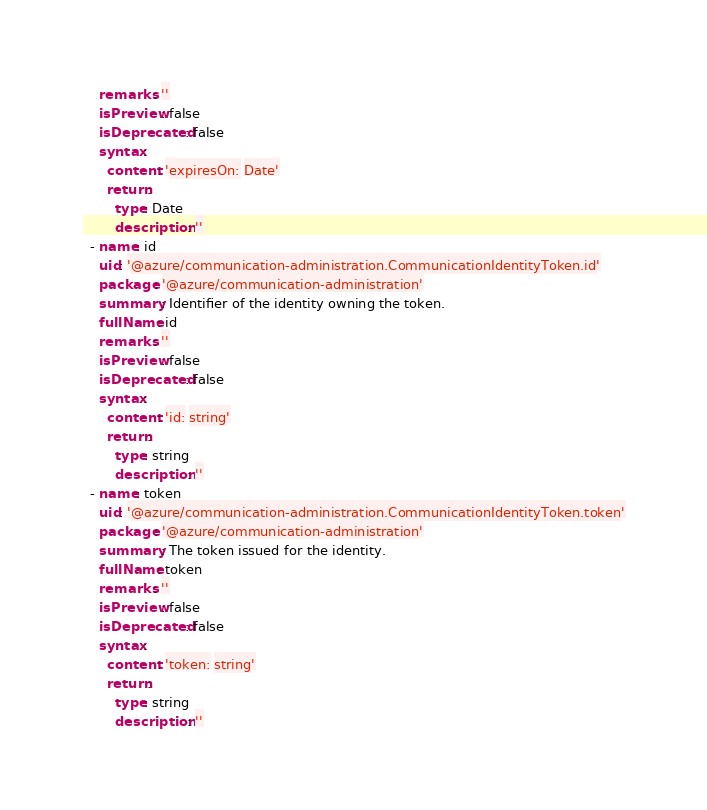Convert code to text. <code><loc_0><loc_0><loc_500><loc_500><_YAML_>    remarks: ''
    isPreview: false
    isDeprecated: false
    syntax:
      content: 'expiresOn: Date'
      return:
        type: Date
        description: ''
  - name: id
    uid: '@azure/communication-administration.CommunicationIdentityToken.id'
    package: '@azure/communication-administration'
    summary: Identifier of the identity owning the token.
    fullName: id
    remarks: ''
    isPreview: false
    isDeprecated: false
    syntax:
      content: 'id: string'
      return:
        type: string
        description: ''
  - name: token
    uid: '@azure/communication-administration.CommunicationIdentityToken.token'
    package: '@azure/communication-administration'
    summary: The token issued for the identity.
    fullName: token
    remarks: ''
    isPreview: false
    isDeprecated: false
    syntax:
      content: 'token: string'
      return:
        type: string
        description: ''
</code> 